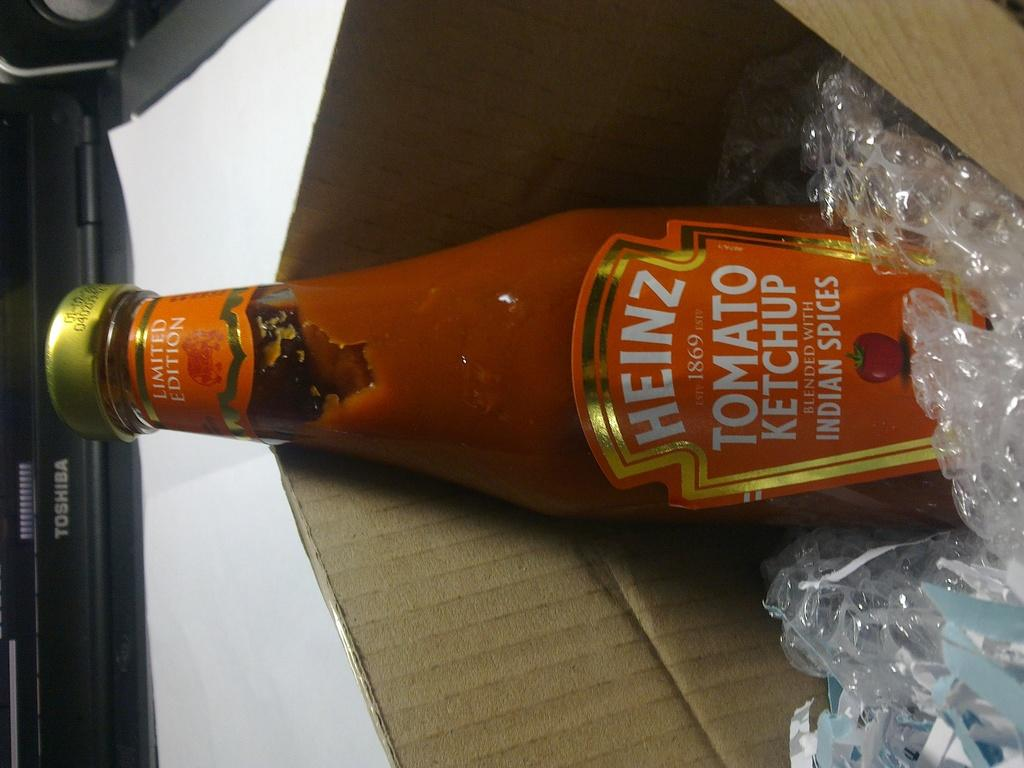<image>
Provide a brief description of the given image. A bottle of Heinz Tomato Ketchup is sticking out of a box with plastic filling. 